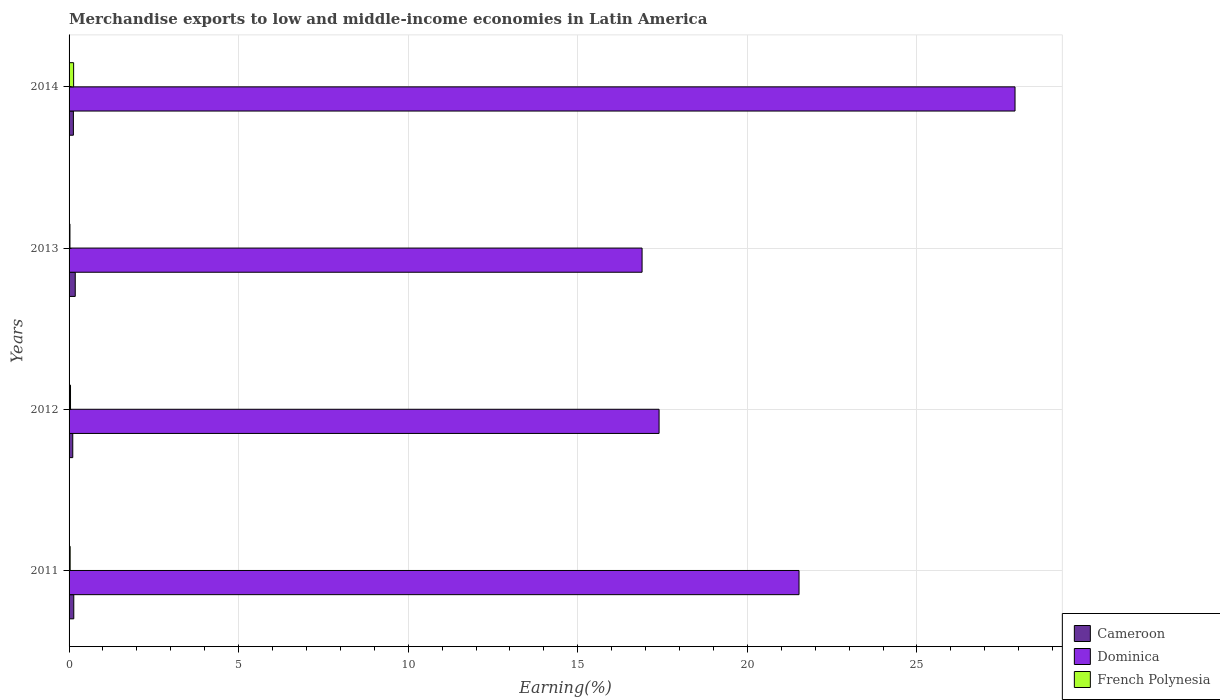Are the number of bars per tick equal to the number of legend labels?
Give a very brief answer. Yes. What is the percentage of amount earned from merchandise exports in Dominica in 2014?
Keep it short and to the point. 27.89. Across all years, what is the maximum percentage of amount earned from merchandise exports in French Polynesia?
Make the answer very short. 0.13. Across all years, what is the minimum percentage of amount earned from merchandise exports in Cameroon?
Provide a short and direct response. 0.11. In which year was the percentage of amount earned from merchandise exports in Cameroon minimum?
Provide a succinct answer. 2012. What is the total percentage of amount earned from merchandise exports in Cameroon in the graph?
Ensure brevity in your answer.  0.56. What is the difference between the percentage of amount earned from merchandise exports in Dominica in 2011 and that in 2014?
Provide a short and direct response. -6.37. What is the difference between the percentage of amount earned from merchandise exports in French Polynesia in 2014 and the percentage of amount earned from merchandise exports in Dominica in 2013?
Your answer should be compact. -16.76. What is the average percentage of amount earned from merchandise exports in Cameroon per year?
Offer a terse response. 0.14. In the year 2011, what is the difference between the percentage of amount earned from merchandise exports in Cameroon and percentage of amount earned from merchandise exports in French Polynesia?
Offer a terse response. 0.11. In how many years, is the percentage of amount earned from merchandise exports in Cameroon greater than 20 %?
Make the answer very short. 0. What is the ratio of the percentage of amount earned from merchandise exports in French Polynesia in 2011 to that in 2014?
Offer a very short reply. 0.24. Is the percentage of amount earned from merchandise exports in Dominica in 2011 less than that in 2012?
Make the answer very short. No. What is the difference between the highest and the second highest percentage of amount earned from merchandise exports in French Polynesia?
Make the answer very short. 0.09. What is the difference between the highest and the lowest percentage of amount earned from merchandise exports in Cameroon?
Make the answer very short. 0.07. What does the 3rd bar from the top in 2012 represents?
Your response must be concise. Cameroon. What does the 3rd bar from the bottom in 2013 represents?
Your answer should be very brief. French Polynesia. Are all the bars in the graph horizontal?
Offer a terse response. Yes. How many years are there in the graph?
Keep it short and to the point. 4. What is the difference between two consecutive major ticks on the X-axis?
Make the answer very short. 5. Are the values on the major ticks of X-axis written in scientific E-notation?
Your answer should be very brief. No. Where does the legend appear in the graph?
Ensure brevity in your answer.  Bottom right. How many legend labels are there?
Offer a terse response. 3. How are the legend labels stacked?
Ensure brevity in your answer.  Vertical. What is the title of the graph?
Offer a very short reply. Merchandise exports to low and middle-income economies in Latin America. What is the label or title of the X-axis?
Offer a terse response. Earning(%). What is the Earning(%) of Cameroon in 2011?
Give a very brief answer. 0.14. What is the Earning(%) in Dominica in 2011?
Your response must be concise. 21.52. What is the Earning(%) of French Polynesia in 2011?
Your answer should be compact. 0.03. What is the Earning(%) in Cameroon in 2012?
Ensure brevity in your answer.  0.11. What is the Earning(%) of Dominica in 2012?
Offer a very short reply. 17.4. What is the Earning(%) of French Polynesia in 2012?
Provide a short and direct response. 0.04. What is the Earning(%) in Cameroon in 2013?
Offer a very short reply. 0.18. What is the Earning(%) of Dominica in 2013?
Provide a short and direct response. 16.89. What is the Earning(%) of French Polynesia in 2013?
Your answer should be very brief. 0.03. What is the Earning(%) in Cameroon in 2014?
Your response must be concise. 0.13. What is the Earning(%) of Dominica in 2014?
Ensure brevity in your answer.  27.89. What is the Earning(%) of French Polynesia in 2014?
Make the answer very short. 0.13. Across all years, what is the maximum Earning(%) of Cameroon?
Give a very brief answer. 0.18. Across all years, what is the maximum Earning(%) of Dominica?
Your response must be concise. 27.89. Across all years, what is the maximum Earning(%) in French Polynesia?
Provide a short and direct response. 0.13. Across all years, what is the minimum Earning(%) in Cameroon?
Offer a terse response. 0.11. Across all years, what is the minimum Earning(%) in Dominica?
Ensure brevity in your answer.  16.89. Across all years, what is the minimum Earning(%) of French Polynesia?
Provide a succinct answer. 0.03. What is the total Earning(%) of Cameroon in the graph?
Your response must be concise. 0.56. What is the total Earning(%) of Dominica in the graph?
Offer a terse response. 83.7. What is the total Earning(%) in French Polynesia in the graph?
Make the answer very short. 0.24. What is the difference between the Earning(%) of Cameroon in 2011 and that in 2012?
Your answer should be very brief. 0.03. What is the difference between the Earning(%) in Dominica in 2011 and that in 2012?
Ensure brevity in your answer.  4.13. What is the difference between the Earning(%) of French Polynesia in 2011 and that in 2012?
Make the answer very short. -0.01. What is the difference between the Earning(%) in Cameroon in 2011 and that in 2013?
Your response must be concise. -0.04. What is the difference between the Earning(%) in Dominica in 2011 and that in 2013?
Provide a succinct answer. 4.63. What is the difference between the Earning(%) of French Polynesia in 2011 and that in 2013?
Your response must be concise. 0.01. What is the difference between the Earning(%) of Cameroon in 2011 and that in 2014?
Your answer should be very brief. 0.01. What is the difference between the Earning(%) in Dominica in 2011 and that in 2014?
Ensure brevity in your answer.  -6.37. What is the difference between the Earning(%) of French Polynesia in 2011 and that in 2014?
Make the answer very short. -0.1. What is the difference between the Earning(%) of Cameroon in 2012 and that in 2013?
Keep it short and to the point. -0.07. What is the difference between the Earning(%) of Dominica in 2012 and that in 2013?
Offer a very short reply. 0.5. What is the difference between the Earning(%) in French Polynesia in 2012 and that in 2013?
Keep it short and to the point. 0.02. What is the difference between the Earning(%) in Cameroon in 2012 and that in 2014?
Make the answer very short. -0.02. What is the difference between the Earning(%) of Dominica in 2012 and that in 2014?
Offer a very short reply. -10.49. What is the difference between the Earning(%) of French Polynesia in 2012 and that in 2014?
Your answer should be very brief. -0.09. What is the difference between the Earning(%) of Cameroon in 2013 and that in 2014?
Provide a short and direct response. 0.05. What is the difference between the Earning(%) of Dominica in 2013 and that in 2014?
Provide a succinct answer. -11. What is the difference between the Earning(%) in French Polynesia in 2013 and that in 2014?
Offer a terse response. -0.11. What is the difference between the Earning(%) in Cameroon in 2011 and the Earning(%) in Dominica in 2012?
Keep it short and to the point. -17.26. What is the difference between the Earning(%) in Cameroon in 2011 and the Earning(%) in French Polynesia in 2012?
Your answer should be compact. 0.1. What is the difference between the Earning(%) of Dominica in 2011 and the Earning(%) of French Polynesia in 2012?
Your answer should be compact. 21.48. What is the difference between the Earning(%) in Cameroon in 2011 and the Earning(%) in Dominica in 2013?
Ensure brevity in your answer.  -16.76. What is the difference between the Earning(%) in Cameroon in 2011 and the Earning(%) in French Polynesia in 2013?
Offer a terse response. 0.11. What is the difference between the Earning(%) of Dominica in 2011 and the Earning(%) of French Polynesia in 2013?
Make the answer very short. 21.5. What is the difference between the Earning(%) in Cameroon in 2011 and the Earning(%) in Dominica in 2014?
Your response must be concise. -27.75. What is the difference between the Earning(%) in Cameroon in 2011 and the Earning(%) in French Polynesia in 2014?
Provide a short and direct response. 0. What is the difference between the Earning(%) of Dominica in 2011 and the Earning(%) of French Polynesia in 2014?
Provide a succinct answer. 21.39. What is the difference between the Earning(%) in Cameroon in 2012 and the Earning(%) in Dominica in 2013?
Provide a succinct answer. -16.79. What is the difference between the Earning(%) of Cameroon in 2012 and the Earning(%) of French Polynesia in 2013?
Provide a short and direct response. 0.08. What is the difference between the Earning(%) of Dominica in 2012 and the Earning(%) of French Polynesia in 2013?
Provide a succinct answer. 17.37. What is the difference between the Earning(%) of Cameroon in 2012 and the Earning(%) of Dominica in 2014?
Keep it short and to the point. -27.78. What is the difference between the Earning(%) of Cameroon in 2012 and the Earning(%) of French Polynesia in 2014?
Keep it short and to the point. -0.03. What is the difference between the Earning(%) of Dominica in 2012 and the Earning(%) of French Polynesia in 2014?
Offer a terse response. 17.26. What is the difference between the Earning(%) of Cameroon in 2013 and the Earning(%) of Dominica in 2014?
Offer a very short reply. -27.71. What is the difference between the Earning(%) of Cameroon in 2013 and the Earning(%) of French Polynesia in 2014?
Your response must be concise. 0.05. What is the difference between the Earning(%) in Dominica in 2013 and the Earning(%) in French Polynesia in 2014?
Keep it short and to the point. 16.76. What is the average Earning(%) of Cameroon per year?
Offer a terse response. 0.14. What is the average Earning(%) of Dominica per year?
Ensure brevity in your answer.  20.93. What is the average Earning(%) in French Polynesia per year?
Your answer should be very brief. 0.06. In the year 2011, what is the difference between the Earning(%) in Cameroon and Earning(%) in Dominica?
Your answer should be very brief. -21.38. In the year 2011, what is the difference between the Earning(%) in Cameroon and Earning(%) in French Polynesia?
Your answer should be compact. 0.11. In the year 2011, what is the difference between the Earning(%) in Dominica and Earning(%) in French Polynesia?
Ensure brevity in your answer.  21.49. In the year 2012, what is the difference between the Earning(%) of Cameroon and Earning(%) of Dominica?
Your answer should be very brief. -17.29. In the year 2012, what is the difference between the Earning(%) in Cameroon and Earning(%) in French Polynesia?
Offer a very short reply. 0.07. In the year 2012, what is the difference between the Earning(%) in Dominica and Earning(%) in French Polynesia?
Make the answer very short. 17.35. In the year 2013, what is the difference between the Earning(%) in Cameroon and Earning(%) in Dominica?
Make the answer very short. -16.71. In the year 2013, what is the difference between the Earning(%) of Cameroon and Earning(%) of French Polynesia?
Ensure brevity in your answer.  0.16. In the year 2013, what is the difference between the Earning(%) in Dominica and Earning(%) in French Polynesia?
Ensure brevity in your answer.  16.87. In the year 2014, what is the difference between the Earning(%) of Cameroon and Earning(%) of Dominica?
Make the answer very short. -27.76. In the year 2014, what is the difference between the Earning(%) of Cameroon and Earning(%) of French Polynesia?
Keep it short and to the point. -0.01. In the year 2014, what is the difference between the Earning(%) in Dominica and Earning(%) in French Polynesia?
Make the answer very short. 27.76. What is the ratio of the Earning(%) of Cameroon in 2011 to that in 2012?
Your answer should be very brief. 1.27. What is the ratio of the Earning(%) of Dominica in 2011 to that in 2012?
Ensure brevity in your answer.  1.24. What is the ratio of the Earning(%) in French Polynesia in 2011 to that in 2012?
Provide a succinct answer. 0.75. What is the ratio of the Earning(%) in Cameroon in 2011 to that in 2013?
Give a very brief answer. 0.76. What is the ratio of the Earning(%) in Dominica in 2011 to that in 2013?
Ensure brevity in your answer.  1.27. What is the ratio of the Earning(%) of French Polynesia in 2011 to that in 2013?
Your answer should be very brief. 1.22. What is the ratio of the Earning(%) in Cameroon in 2011 to that in 2014?
Your response must be concise. 1.09. What is the ratio of the Earning(%) in Dominica in 2011 to that in 2014?
Provide a succinct answer. 0.77. What is the ratio of the Earning(%) in French Polynesia in 2011 to that in 2014?
Offer a very short reply. 0.24. What is the ratio of the Earning(%) in Cameroon in 2012 to that in 2013?
Make the answer very short. 0.6. What is the ratio of the Earning(%) in Dominica in 2012 to that in 2013?
Provide a short and direct response. 1.03. What is the ratio of the Earning(%) in French Polynesia in 2012 to that in 2013?
Provide a short and direct response. 1.63. What is the ratio of the Earning(%) of Cameroon in 2012 to that in 2014?
Offer a very short reply. 0.86. What is the ratio of the Earning(%) of Dominica in 2012 to that in 2014?
Provide a short and direct response. 0.62. What is the ratio of the Earning(%) in French Polynesia in 2012 to that in 2014?
Your answer should be very brief. 0.32. What is the ratio of the Earning(%) of Cameroon in 2013 to that in 2014?
Your answer should be compact. 1.43. What is the ratio of the Earning(%) in Dominica in 2013 to that in 2014?
Give a very brief answer. 0.61. What is the ratio of the Earning(%) in French Polynesia in 2013 to that in 2014?
Make the answer very short. 0.2. What is the difference between the highest and the second highest Earning(%) of Cameroon?
Provide a succinct answer. 0.04. What is the difference between the highest and the second highest Earning(%) in Dominica?
Give a very brief answer. 6.37. What is the difference between the highest and the second highest Earning(%) in French Polynesia?
Offer a very short reply. 0.09. What is the difference between the highest and the lowest Earning(%) of Cameroon?
Your answer should be very brief. 0.07. What is the difference between the highest and the lowest Earning(%) in Dominica?
Offer a very short reply. 11. What is the difference between the highest and the lowest Earning(%) in French Polynesia?
Provide a succinct answer. 0.11. 